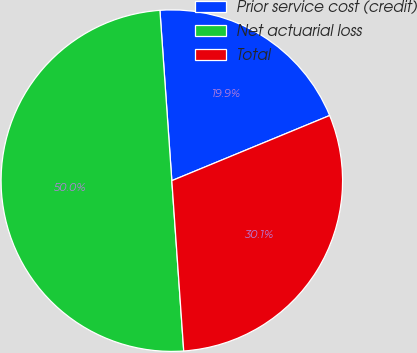Convert chart. <chart><loc_0><loc_0><loc_500><loc_500><pie_chart><fcel>Prior service cost (credit)<fcel>Net actuarial loss<fcel>Total<nl><fcel>19.88%<fcel>50.0%<fcel>30.12%<nl></chart> 